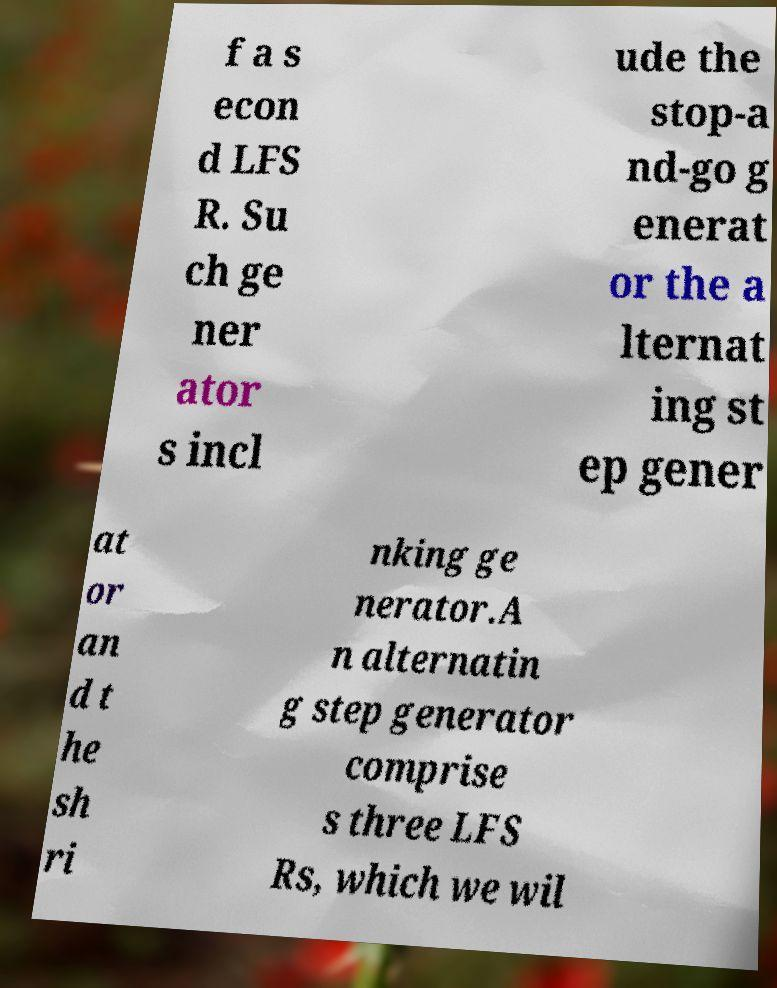Please identify and transcribe the text found in this image. f a s econ d LFS R. Su ch ge ner ator s incl ude the stop-a nd-go g enerat or the a lternat ing st ep gener at or an d t he sh ri nking ge nerator.A n alternatin g step generator comprise s three LFS Rs, which we wil 